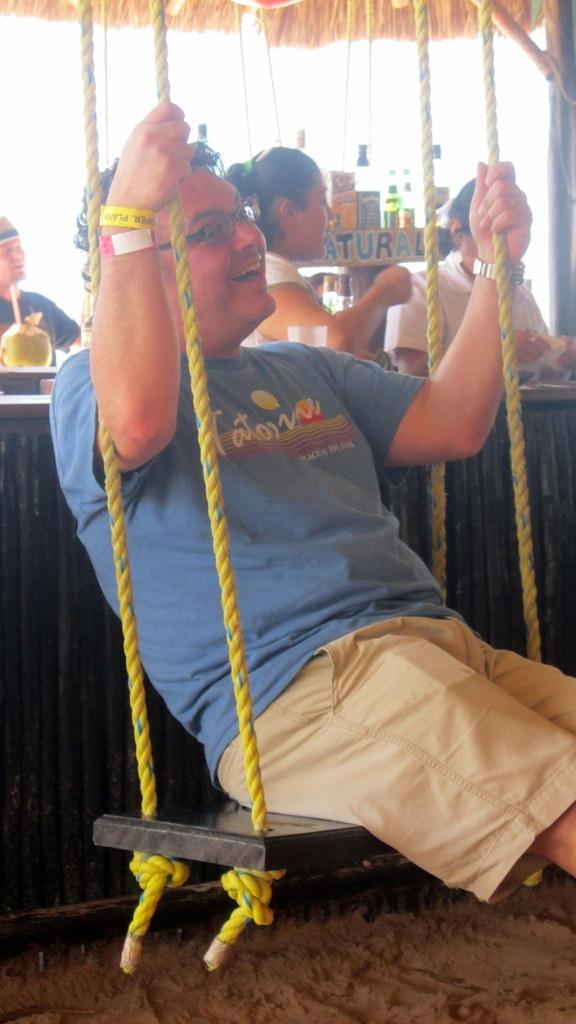What is the man in the image doing? The man is sitting and holding ropes with his hands. What can be seen in the background of the image? There are people, bottles, a coconut, and other objects in the background of the image. Can you describe the objects in the background? The objects in the background include bottles and a coconut, but their specific nature cannot be determined from the provided facts. What is the name of the ground in the image? There is no specific ground mentioned or visible in the image, so it is not possible to determine its name. 